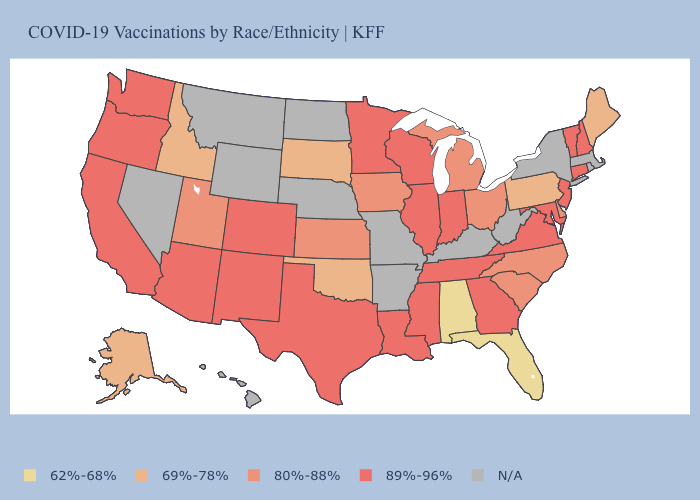Does Maine have the lowest value in the Northeast?
Give a very brief answer. Yes. Does the first symbol in the legend represent the smallest category?
Quick response, please. Yes. What is the value of Virginia?
Be succinct. 89%-96%. Name the states that have a value in the range 89%-96%?
Answer briefly. Arizona, California, Colorado, Connecticut, Georgia, Illinois, Indiana, Louisiana, Maryland, Minnesota, Mississippi, New Hampshire, New Jersey, New Mexico, Oregon, Tennessee, Texas, Vermont, Virginia, Washington, Wisconsin. What is the value of Maryland?
Be succinct. 89%-96%. Name the states that have a value in the range 80%-88%?
Be succinct. Delaware, Iowa, Kansas, Michigan, North Carolina, Ohio, South Carolina, Utah. Name the states that have a value in the range 69%-78%?
Concise answer only. Alaska, Idaho, Maine, Oklahoma, Pennsylvania, South Dakota. Name the states that have a value in the range 80%-88%?
Give a very brief answer. Delaware, Iowa, Kansas, Michigan, North Carolina, Ohio, South Carolina, Utah. What is the value of Pennsylvania?
Be succinct. 69%-78%. What is the highest value in the USA?
Short answer required. 89%-96%. Which states have the lowest value in the USA?
Short answer required. Alabama, Florida. What is the lowest value in the MidWest?
Give a very brief answer. 69%-78%. 